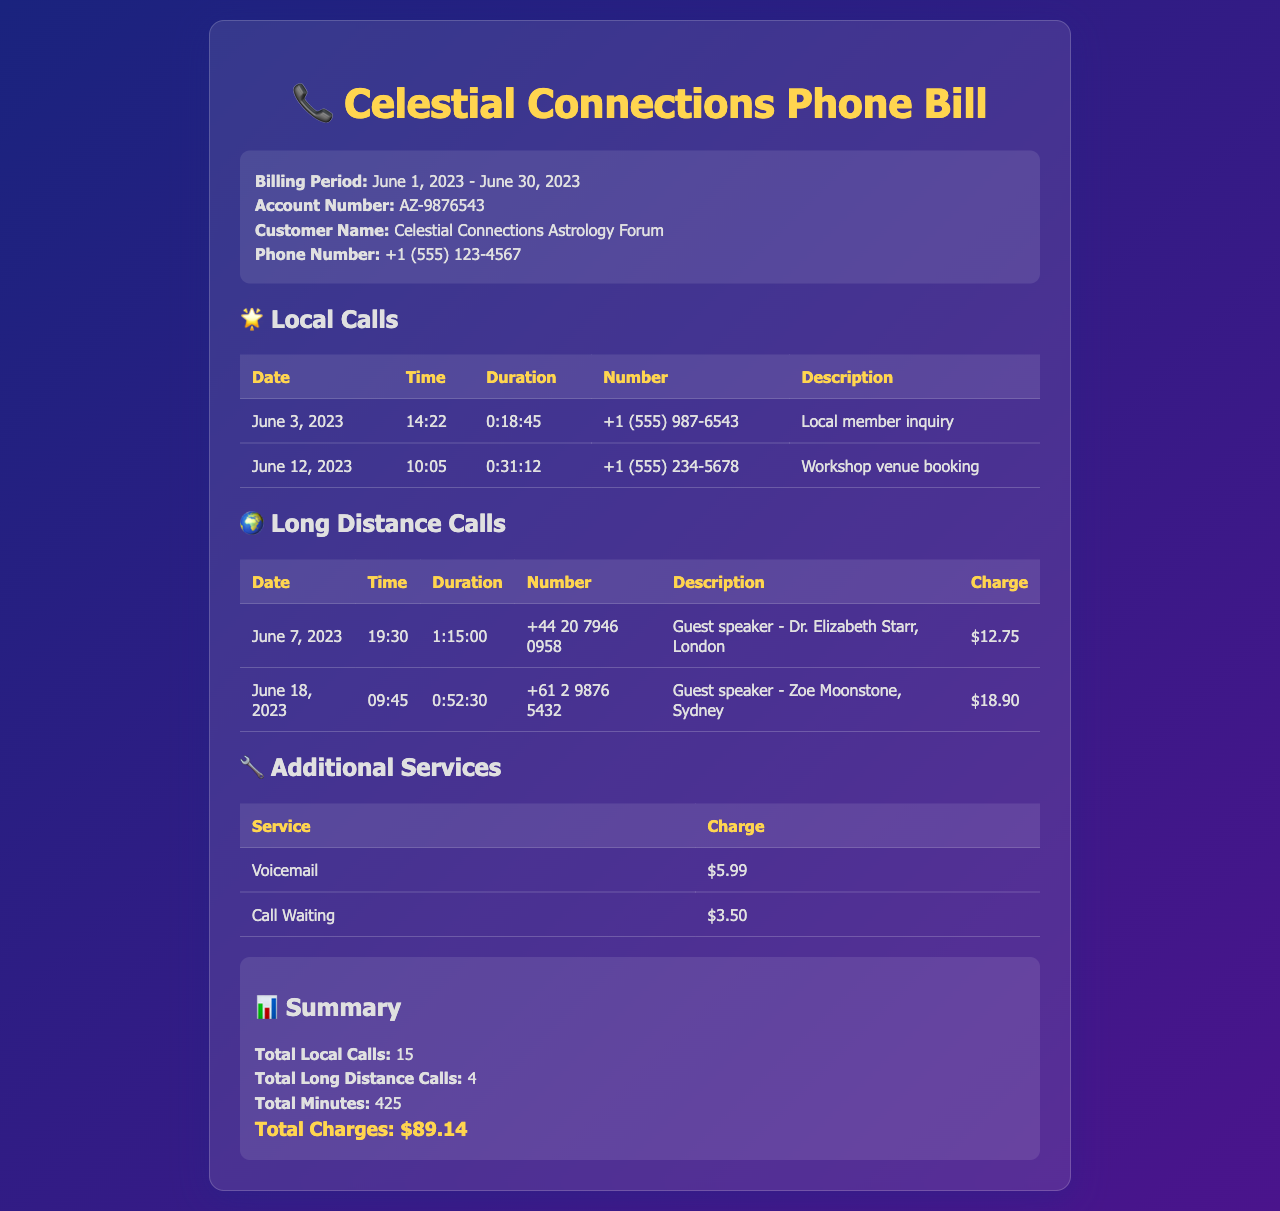What is the account number? The account number is listed in the header section of the document.
Answer: AZ-9876543 Who was the guest speaker from Sydney? The table of long-distance calls includes the names of guest speakers and their locations.
Answer: Zoe Moonstone What is the duration of the call to Dr. Elizabeth Starr? The duration is provided in the long-distance calls table for each entry.
Answer: 1:15:00 How many local calls were made? The summary section specifies the total count of local calls made during the billing period.
Answer: 15 What was the total charge for voicemail? The additional services table lists the charges for each type of service.
Answer: $5.99 What is the total charge for long-distance calls? The total charge can be calculated by adding the individual charges for long-distance calls given in the table.
Answer: $31.65 When was the call made to Zoe Moonstone? The date is provided in the long-distance calls table alongside the other details.
Answer: June 18, 2023 What is the total amount due for all charges? The total charges are summarized at the bottom of the document reflecting all costs incurred.
Answer: $89.14 